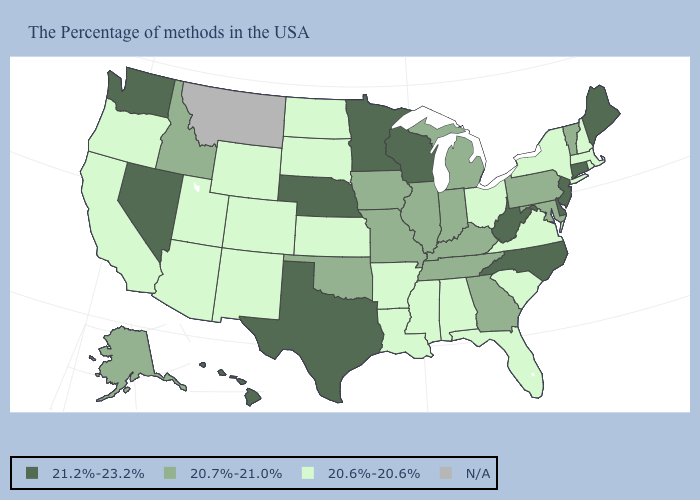What is the value of Connecticut?
Concise answer only. 21.2%-23.2%. Name the states that have a value in the range 20.7%-21.0%?
Keep it brief. Vermont, Maryland, Pennsylvania, Georgia, Michigan, Kentucky, Indiana, Tennessee, Illinois, Missouri, Iowa, Oklahoma, Idaho, Alaska. Name the states that have a value in the range 20.7%-21.0%?
Quick response, please. Vermont, Maryland, Pennsylvania, Georgia, Michigan, Kentucky, Indiana, Tennessee, Illinois, Missouri, Iowa, Oklahoma, Idaho, Alaska. Name the states that have a value in the range 20.7%-21.0%?
Concise answer only. Vermont, Maryland, Pennsylvania, Georgia, Michigan, Kentucky, Indiana, Tennessee, Illinois, Missouri, Iowa, Oklahoma, Idaho, Alaska. What is the value of Massachusetts?
Short answer required. 20.6%-20.6%. Name the states that have a value in the range 20.7%-21.0%?
Concise answer only. Vermont, Maryland, Pennsylvania, Georgia, Michigan, Kentucky, Indiana, Tennessee, Illinois, Missouri, Iowa, Oklahoma, Idaho, Alaska. Which states have the highest value in the USA?
Give a very brief answer. Maine, Connecticut, New Jersey, Delaware, North Carolina, West Virginia, Wisconsin, Minnesota, Nebraska, Texas, Nevada, Washington, Hawaii. What is the lowest value in states that border Delaware?
Answer briefly. 20.7%-21.0%. Is the legend a continuous bar?
Keep it brief. No. What is the lowest value in the South?
Answer briefly. 20.6%-20.6%. Name the states that have a value in the range 20.6%-20.6%?
Be succinct. Massachusetts, Rhode Island, New Hampshire, New York, Virginia, South Carolina, Ohio, Florida, Alabama, Mississippi, Louisiana, Arkansas, Kansas, South Dakota, North Dakota, Wyoming, Colorado, New Mexico, Utah, Arizona, California, Oregon. What is the value of Massachusetts?
Quick response, please. 20.6%-20.6%. Among the states that border South Carolina , does North Carolina have the highest value?
Write a very short answer. Yes. What is the highest value in the West ?
Short answer required. 21.2%-23.2%. Which states have the lowest value in the Northeast?
Answer briefly. Massachusetts, Rhode Island, New Hampshire, New York. 